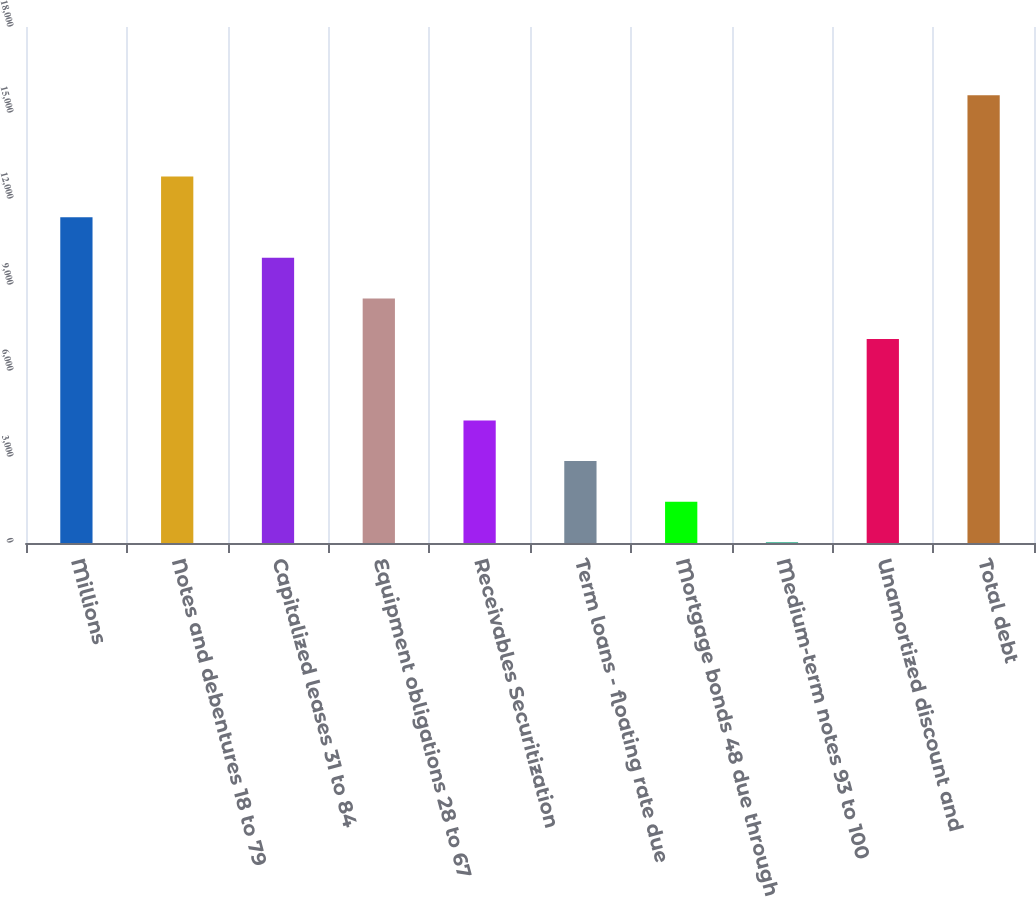Convert chart. <chart><loc_0><loc_0><loc_500><loc_500><bar_chart><fcel>Millions<fcel>Notes and debentures 18 to 79<fcel>Capitalized leases 31 to 84<fcel>Equipment obligations 28 to 67<fcel>Receivables Securitization<fcel>Term loans - floating rate due<fcel>Mortgage bonds 48 due through<fcel>Medium-term notes 93 to 100<fcel>Unamortized discount and<fcel>Total debt<nl><fcel>11365.4<fcel>12783.2<fcel>9947.6<fcel>8529.8<fcel>4276.4<fcel>2858.6<fcel>1440.8<fcel>23<fcel>7112<fcel>15618.8<nl></chart> 